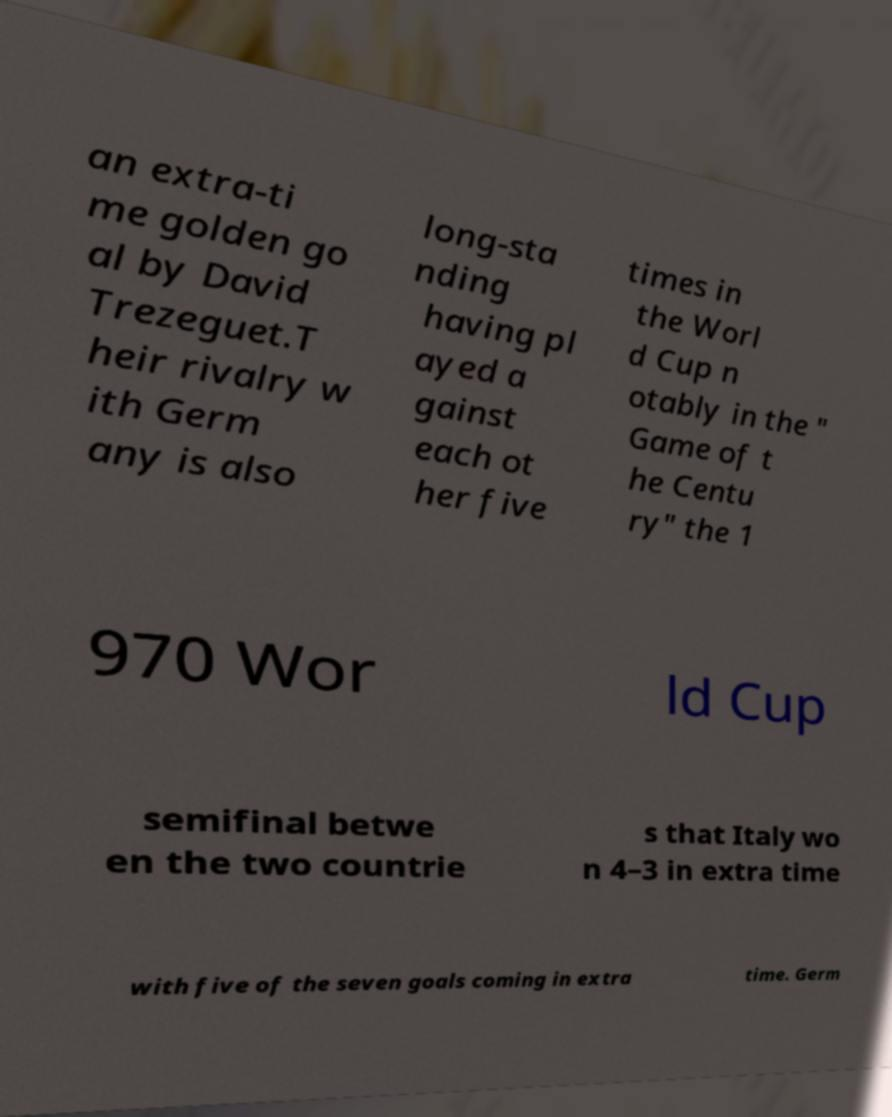Please read and relay the text visible in this image. What does it say? an extra-ti me golden go al by David Trezeguet.T heir rivalry w ith Germ any is also long-sta nding having pl ayed a gainst each ot her five times in the Worl d Cup n otably in the " Game of t he Centu ry" the 1 970 Wor ld Cup semifinal betwe en the two countrie s that Italy wo n 4–3 in extra time with five of the seven goals coming in extra time. Germ 